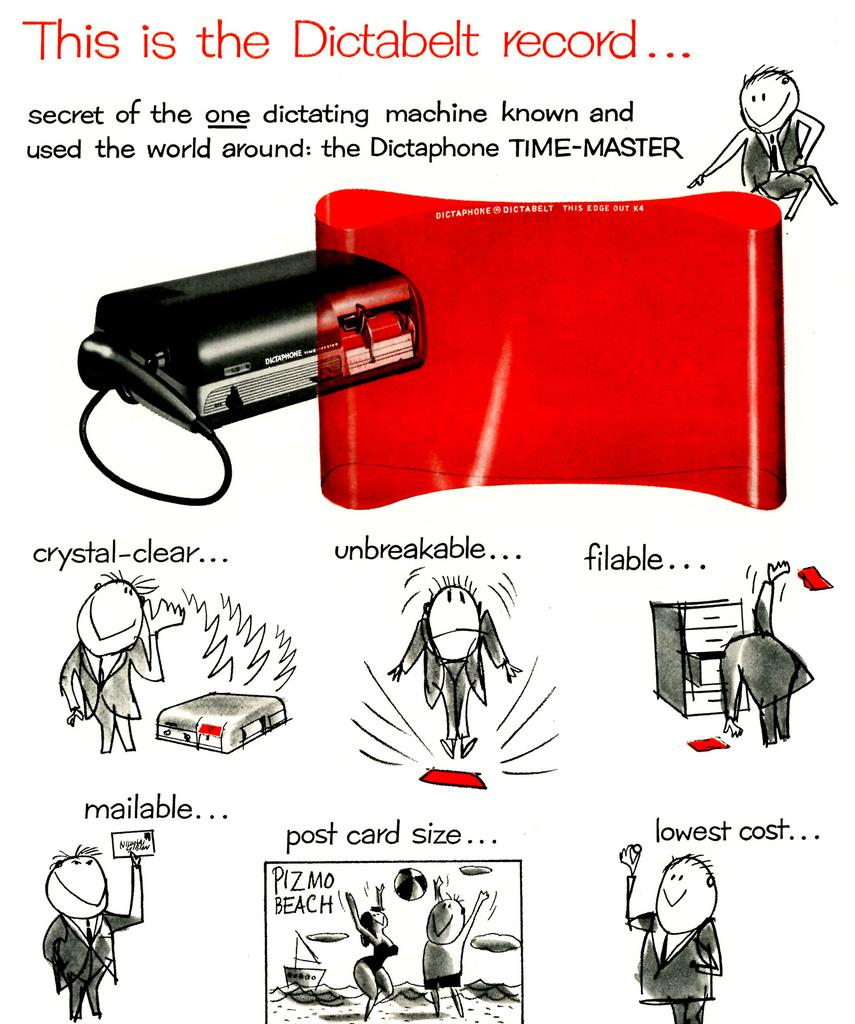<image>
Offer a succinct explanation of the picture presented. A short cartoon about the dictaphone dictating machine. 